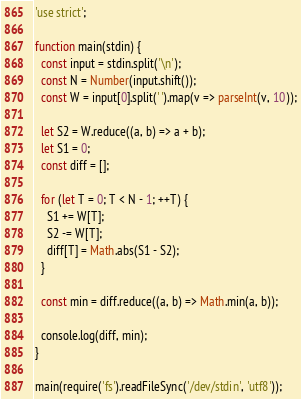Convert code to text. <code><loc_0><loc_0><loc_500><loc_500><_JavaScript_>'use strict';

function main(stdin) {
  const input = stdin.split('\n');
  const N = Number(input.shift());
  const W = input[0].split(' ').map(v => parseInt(v, 10));

  let S2 = W.reduce((a, b) => a + b);
  let S1 = 0;
  const diff = [];

  for (let T = 0; T < N - 1; ++T) {
    S1 += W[T];
    S2 -= W[T];
    diff[T] = Math.abs(S1 - S2);
  }

  const min = diff.reduce((a, b) => Math.min(a, b));
  
  console.log(diff, min);
}

main(require('fs').readFileSync('/dev/stdin', 'utf8'));</code> 